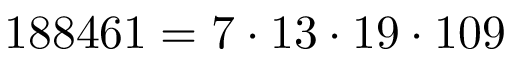Convert formula to latex. <formula><loc_0><loc_0><loc_500><loc_500>1 8 8 4 6 1 = 7 \cdot 1 3 \cdot 1 9 \cdot 1 0 9</formula> 